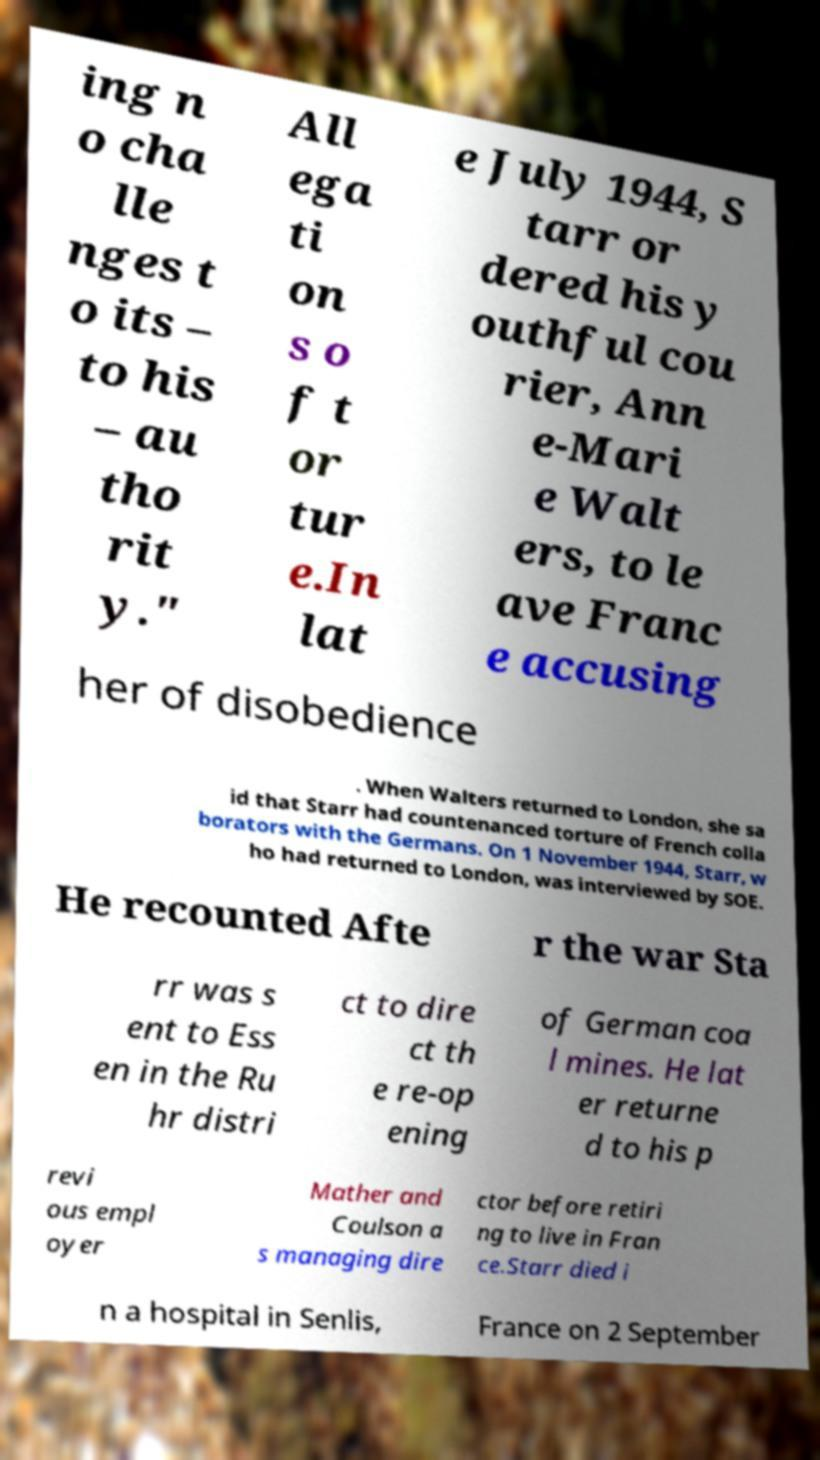Could you extract and type out the text from this image? ing n o cha lle nges t o its – to his – au tho rit y." All ega ti on s o f t or tur e.In lat e July 1944, S tarr or dered his y outhful cou rier, Ann e-Mari e Walt ers, to le ave Franc e accusing her of disobedience . When Walters returned to London, she sa id that Starr had countenanced torture of French colla borators with the Germans. On 1 November 1944, Starr, w ho had returned to London, was interviewed by SOE. He recounted Afte r the war Sta rr was s ent to Ess en in the Ru hr distri ct to dire ct th e re-op ening of German coa l mines. He lat er returne d to his p revi ous empl oyer Mather and Coulson a s managing dire ctor before retiri ng to live in Fran ce.Starr died i n a hospital in Senlis, France on 2 September 